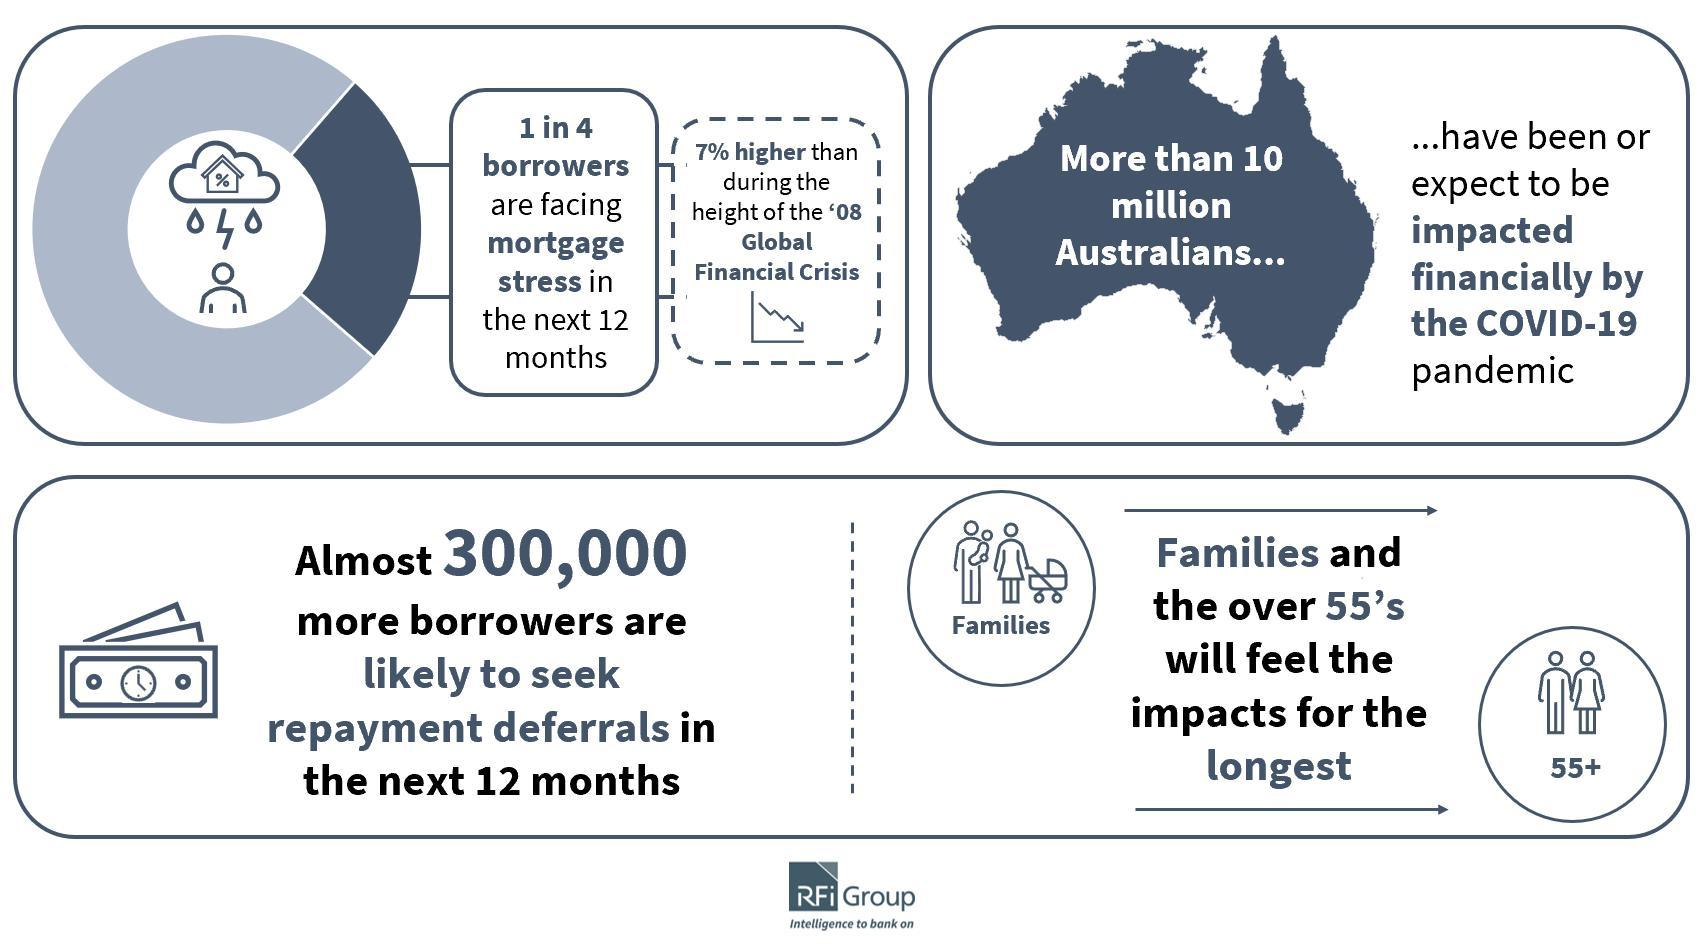Who will be asking for repayment deferrals in the near future?
Answer the question with a short phrase. Almost 300,000 more borrowers Which category of people gets affected by corona the most? Families and the over 55's How many Australians will be affected financially with the pandemic? 10 million 